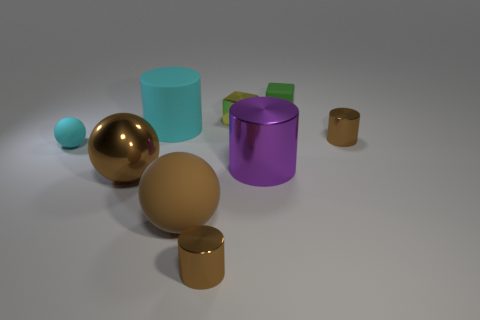There is a brown metallic thing that is behind the cyan matte ball; is it the same size as the large shiny cylinder?
Offer a very short reply. No. What number of small blocks are on the left side of the yellow block behind the small rubber object that is on the left side of the cyan cylinder?
Your response must be concise. 0. There is a cylinder that is in front of the small cyan sphere and left of the yellow shiny cube; what is its size?
Your answer should be compact. Small. How many other objects are the same shape as the large brown shiny object?
Provide a succinct answer. 2. What number of big balls are left of the small matte ball?
Provide a short and direct response. 0. Are there fewer small green blocks on the left side of the purple metal cylinder than tiny brown shiny objects that are left of the yellow metallic object?
Offer a terse response. Yes. There is a small object that is left of the brown cylinder in front of the brown metallic cylinder that is on the right side of the green object; what is its shape?
Give a very brief answer. Sphere. The brown shiny thing that is both on the right side of the matte cylinder and in front of the small ball has what shape?
Your answer should be compact. Cylinder. Is there a red sphere made of the same material as the cyan cylinder?
Your response must be concise. No. What is the size of the thing that is the same color as the large matte cylinder?
Your response must be concise. Small. 